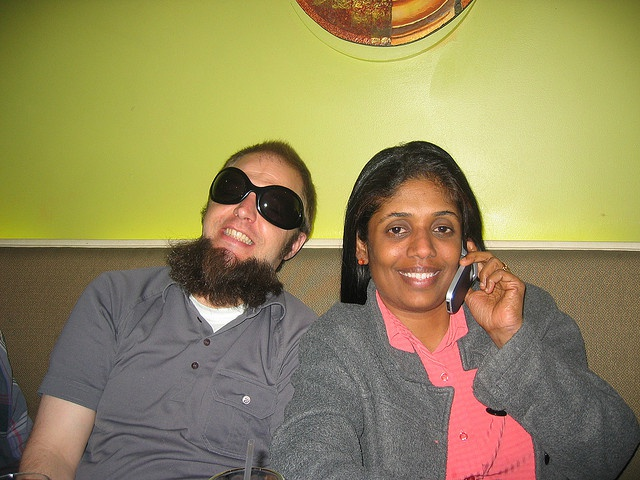Describe the objects in this image and their specific colors. I can see people in darkgreen, gray, black, brown, and salmon tones, people in darkgreen, gray, black, and tan tones, and cell phone in darkgreen, black, maroon, darkgray, and gray tones in this image. 